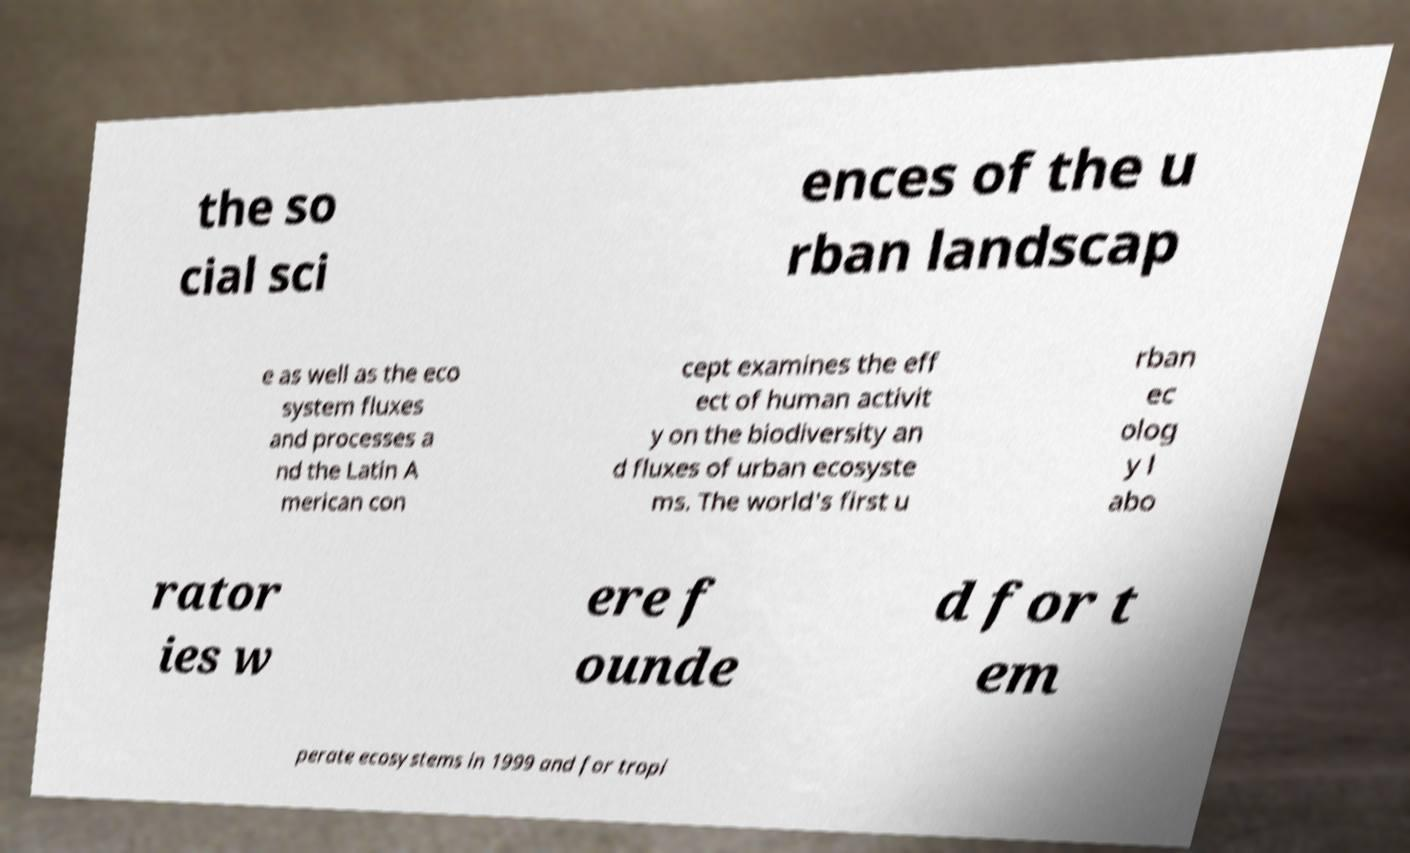Could you extract and type out the text from this image? the so cial sci ences of the u rban landscap e as well as the eco system fluxes and processes a nd the Latin A merican con cept examines the eff ect of human activit y on the biodiversity an d fluxes of urban ecosyste ms. The world's first u rban ec olog y l abo rator ies w ere f ounde d for t em perate ecosystems in 1999 and for tropi 